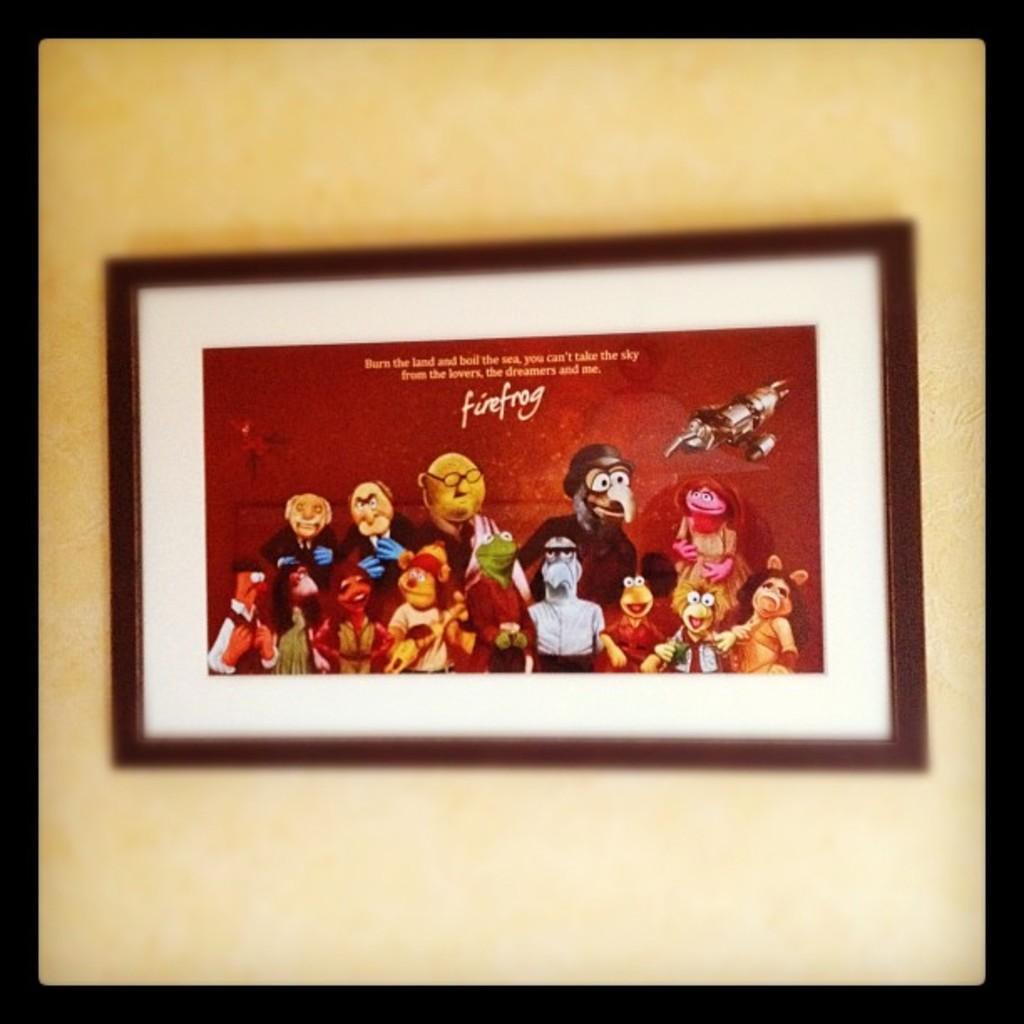Could you give a brief overview of what you see in this image? This picture shows a photo frame on the wall and we see cartoon pictures and text on the top in the photo. 